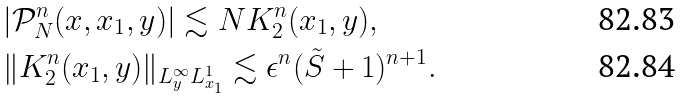<formula> <loc_0><loc_0><loc_500><loc_500>& | \mathcal { P } _ { N } ^ { n } ( x , x _ { 1 } , y ) | \lesssim N K _ { 2 } ^ { n } ( x _ { 1 } , y ) , \\ & \| K _ { 2 } ^ { n } ( x _ { 1 } , y ) \| _ { L _ { y } ^ { \infty } L _ { x _ { 1 } } ^ { 1 } } \lesssim \epsilon ^ { n } ( \tilde { S } + 1 ) ^ { n + 1 } .</formula> 